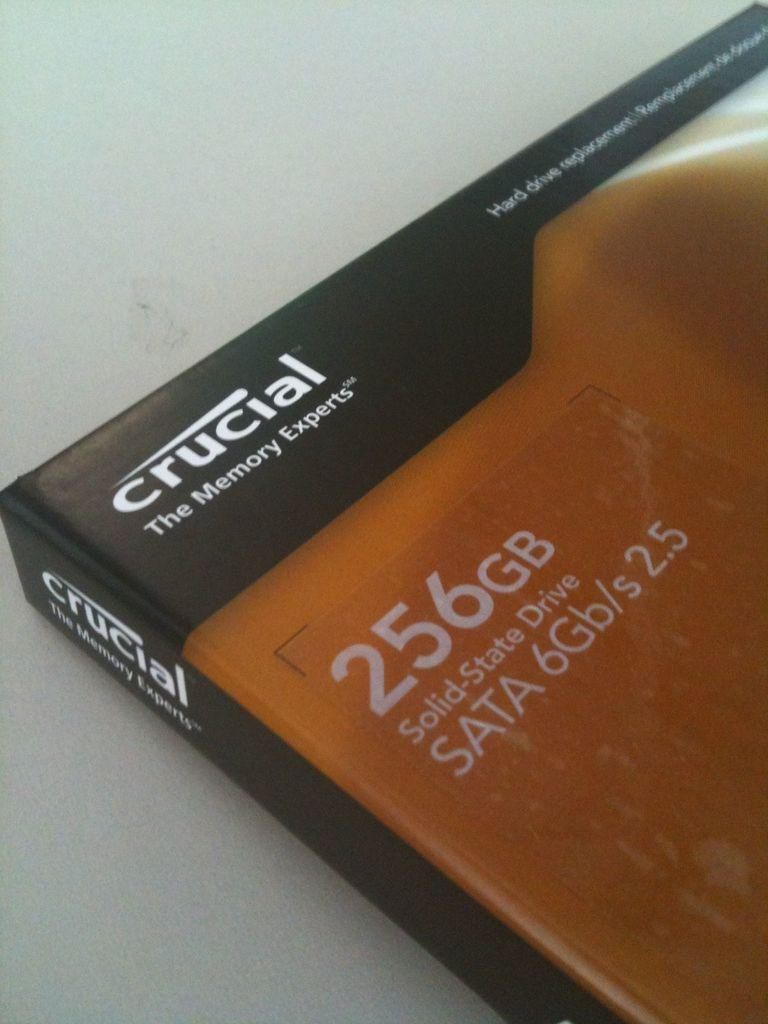<image>
Summarize the visual content of the image. The book claims that the memory experts are Crucial. 